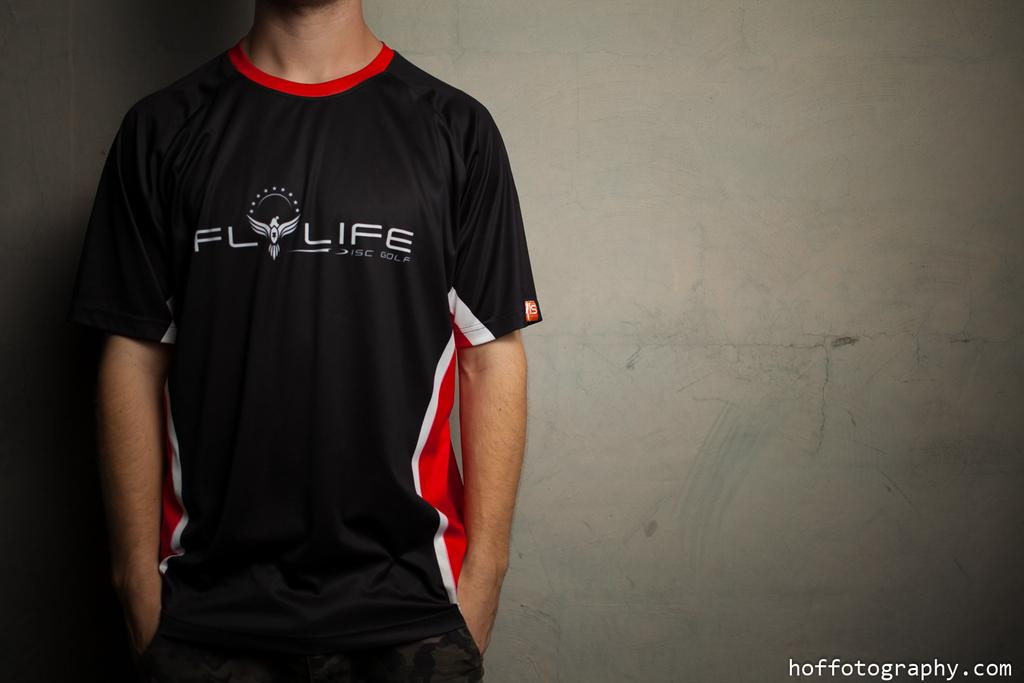<image>
Create a compact narrative representing the image presented. Black jersey with the word "FLY LIFE" on it. 